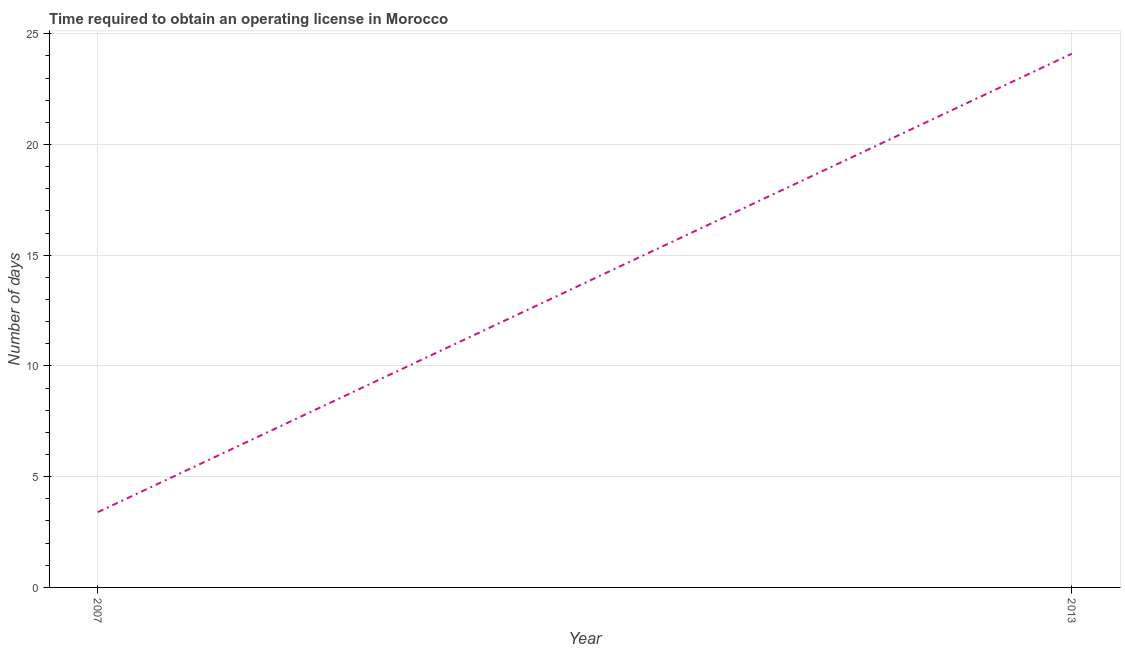What is the number of days to obtain operating license in 2013?
Keep it short and to the point. 24.1. Across all years, what is the maximum number of days to obtain operating license?
Provide a succinct answer. 24.1. In which year was the number of days to obtain operating license maximum?
Give a very brief answer. 2013. What is the difference between the number of days to obtain operating license in 2007 and 2013?
Provide a short and direct response. -20.7. What is the average number of days to obtain operating license per year?
Keep it short and to the point. 13.75. What is the median number of days to obtain operating license?
Offer a very short reply. 13.75. What is the ratio of the number of days to obtain operating license in 2007 to that in 2013?
Provide a succinct answer. 0.14. In how many years, is the number of days to obtain operating license greater than the average number of days to obtain operating license taken over all years?
Your response must be concise. 1. Does the number of days to obtain operating license monotonically increase over the years?
Offer a very short reply. Yes. How many lines are there?
Your response must be concise. 1. How many years are there in the graph?
Ensure brevity in your answer.  2. What is the difference between two consecutive major ticks on the Y-axis?
Provide a succinct answer. 5. Are the values on the major ticks of Y-axis written in scientific E-notation?
Offer a very short reply. No. What is the title of the graph?
Keep it short and to the point. Time required to obtain an operating license in Morocco. What is the label or title of the Y-axis?
Your answer should be very brief. Number of days. What is the Number of days in 2007?
Provide a succinct answer. 3.4. What is the Number of days in 2013?
Your answer should be compact. 24.1. What is the difference between the Number of days in 2007 and 2013?
Your response must be concise. -20.7. What is the ratio of the Number of days in 2007 to that in 2013?
Provide a succinct answer. 0.14. 